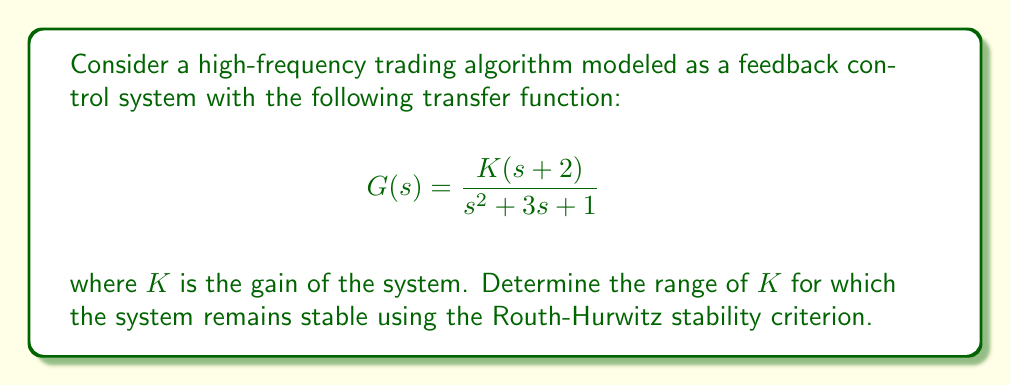Could you help me with this problem? To analyze the stability of this feedback control system, we'll use the Routh-Hurwitz stability criterion. This method allows us to determine the stability of a system without explicitly solving for the roots of the characteristic equation.

Step 1: Identify the characteristic equation
The characteristic equation is given by the denominator of the closed-loop transfer function:

$$1 + G(s) = 0$$
$$1 + \frac{K(s+2)}{s^2 + 3s + 1} = 0$$

Multiplying both sides by the denominator:

$$s^2 + 3s + 1 + K(s+2) = 0$$
$$s^2 + (3+K)s + (1+2K) = 0$$

Step 2: Construct the Routh array
The Routh array for this system is:

$$\begin{array}{c|c}
s^2 & 1 & 1+2K \\
s^1 & 3+K & 0 \\
s^0 & 1+2K & 0
\end{array}$$

Step 3: Analyze the Routh array
For the system to be stable, all elements in the first column of the Routh array must be positive. This gives us the following conditions:

1. $1 > 0$ (always true)
2. $3+K > 0$
3. $1+2K > 0$

Step 4: Solve the inequalities
From condition 2: $3+K > 0$
$K > -3$

From condition 3: $1+2K > 0$
$2K > -1$
$K > -\frac{1}{2}$

Combining these conditions, we get:

$$K > -\frac{1}{2}$$

This is the range of K for which the system remains stable.
Answer: The high-frequency trading algorithm modeled as a feedback control system remains stable for $K > -\frac{1}{2}$. 